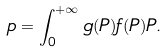<formula> <loc_0><loc_0><loc_500><loc_500>p = \int _ { 0 } ^ { + \infty } g ( P ) f ( P ) P .</formula> 